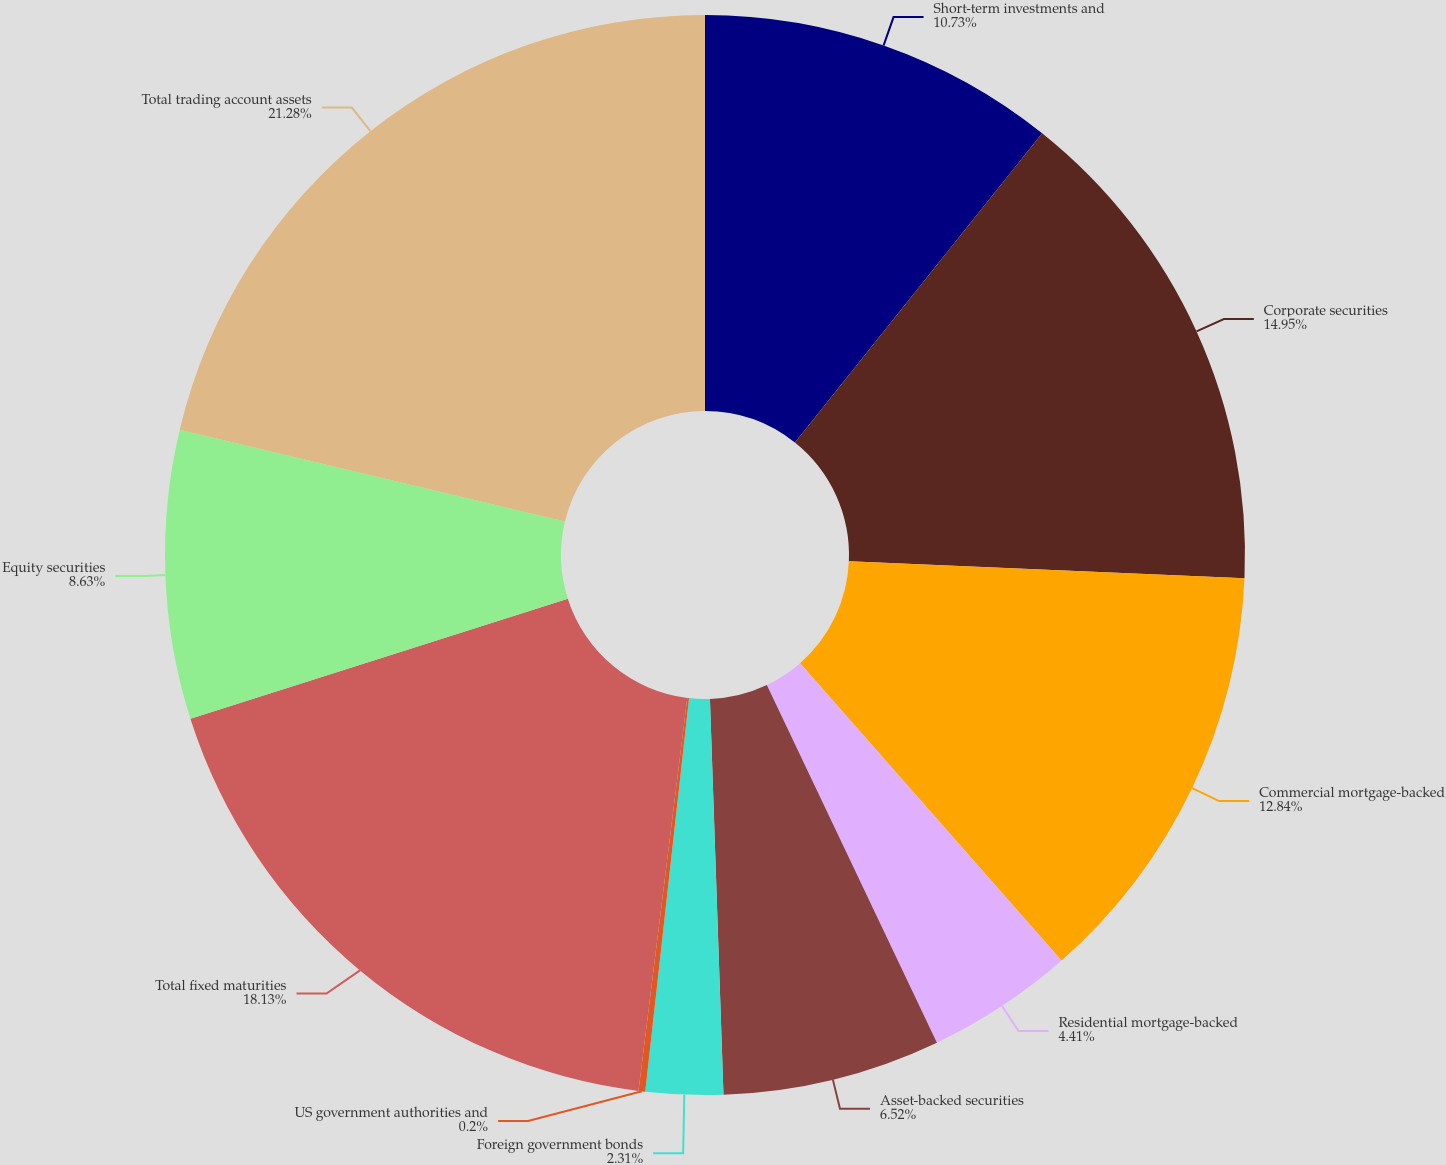Convert chart. <chart><loc_0><loc_0><loc_500><loc_500><pie_chart><fcel>Short-term investments and<fcel>Corporate securities<fcel>Commercial mortgage-backed<fcel>Residential mortgage-backed<fcel>Asset-backed securities<fcel>Foreign government bonds<fcel>US government authorities and<fcel>Total fixed maturities<fcel>Equity securities<fcel>Total trading account assets<nl><fcel>10.73%<fcel>14.95%<fcel>12.84%<fcel>4.41%<fcel>6.52%<fcel>2.31%<fcel>0.2%<fcel>18.13%<fcel>8.63%<fcel>21.27%<nl></chart> 